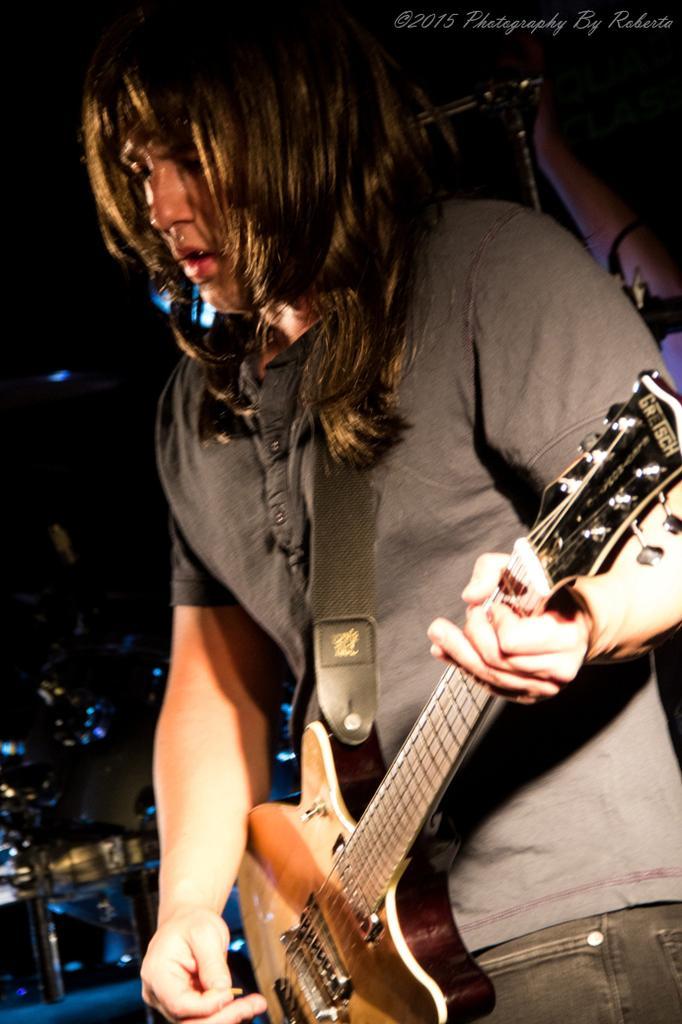Describe this image in one or two sentences. In this image I see a man who is standing and holding a guitar. 